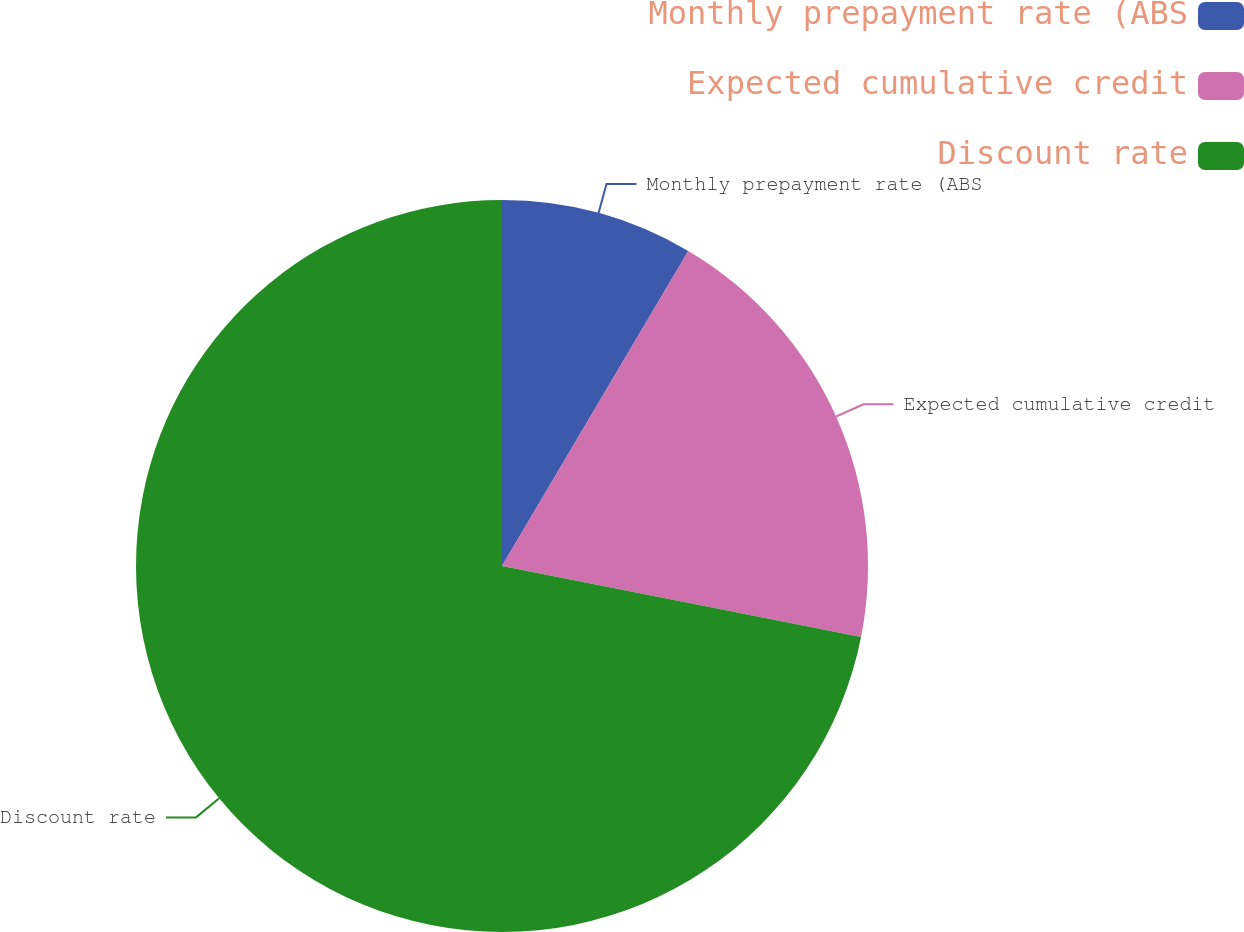Convert chart. <chart><loc_0><loc_0><loc_500><loc_500><pie_chart><fcel>Monthly prepayment rate (ABS<fcel>Expected cumulative credit<fcel>Discount rate<nl><fcel>8.5%<fcel>19.61%<fcel>71.9%<nl></chart> 